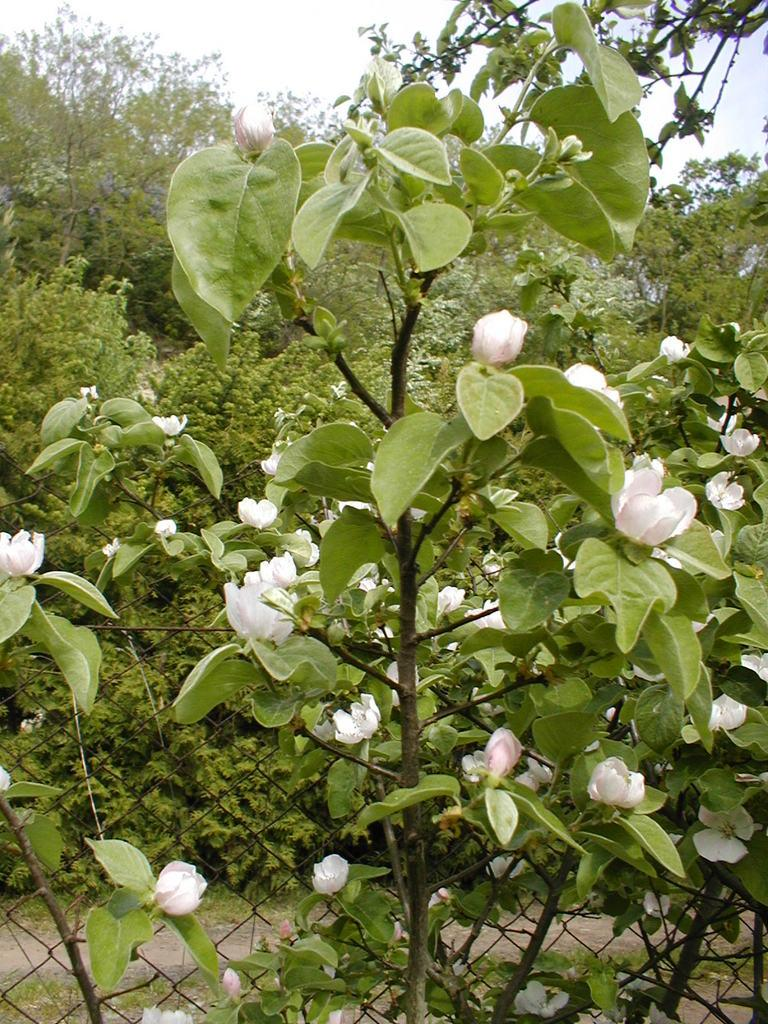What type of plant is visible in the image? There is a plant with flowers in the image. What is the material of the fence in the image? The fence in the image is made of metal. What can be seen in the background of the image? There is a group of trees in the image. What is visible above the trees and fence in the image? The sky is visible in the image. How would you describe the weather based on the appearance of the sky? The sky appears to be cloudy in the image. What type of silk fabric is draped over the plant in the image? There is no silk fabric present in the image; the plant has flowers and is not covered by any fabric. How many legs can be seen supporting the wire in the image? There is no wire present in the image, so it is not possible to determine the number of legs supporting it. 